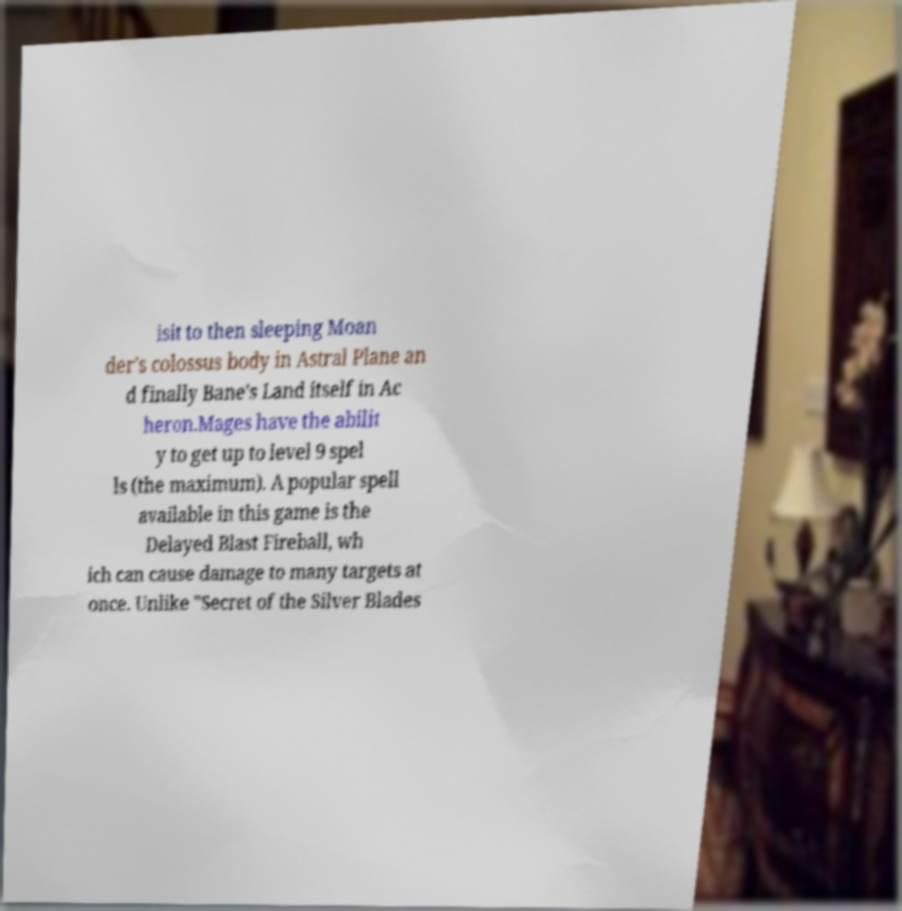Can you accurately transcribe the text from the provided image for me? isit to then sleeping Moan der's colossus body in Astral Plane an d finally Bane's Land itself in Ac heron.Mages have the abilit y to get up to level 9 spel ls (the maximum). A popular spell available in this game is the Delayed Blast Fireball, wh ich can cause damage to many targets at once. Unlike "Secret of the Silver Blades 